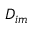Convert formula to latex. <formula><loc_0><loc_0><loc_500><loc_500>D _ { i m }</formula> 